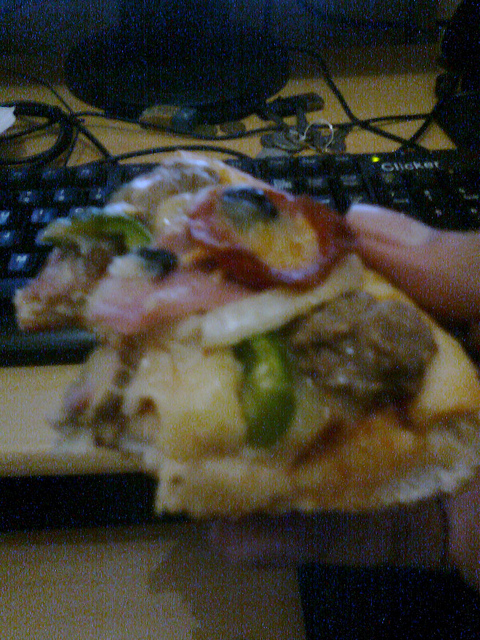Are these vegetarian pizzas? No, these pizzas appear to have various non-vegetarian toppings such as ham and possibly other meats. 